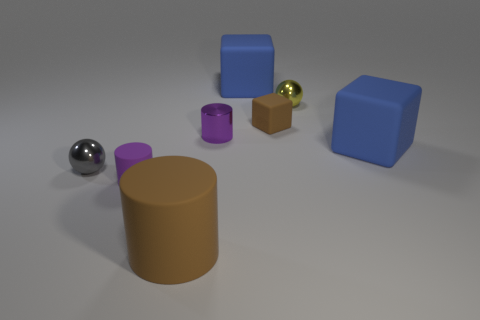Is the material of the yellow sphere the same as the small cylinder that is behind the tiny gray sphere?
Offer a terse response. Yes. There is a metallic thing that is behind the tiny purple object that is behind the small gray ball; what is its size?
Your response must be concise. Small. Is there any other thing that has the same color as the small rubber cube?
Your answer should be very brief. Yes. Is the tiny cylinder behind the purple rubber cylinder made of the same material as the brown object that is behind the small gray shiny sphere?
Make the answer very short. No. There is a tiny thing that is both left of the small brown object and on the right side of the large cylinder; what is it made of?
Offer a terse response. Metal. Does the purple metal thing have the same shape as the blue thing that is to the left of the tiny brown cube?
Ensure brevity in your answer.  No. What material is the cylinder that is to the left of the brown rubber thing in front of the tiny cylinder left of the big matte cylinder?
Keep it short and to the point. Rubber. What number of other things are the same size as the purple matte cylinder?
Provide a short and direct response. 4. Do the large cylinder and the small rubber cube have the same color?
Your response must be concise. Yes. There is a cylinder on the left side of the brown object in front of the tiny purple matte object; how many big blue rubber blocks are right of it?
Give a very brief answer. 2. 